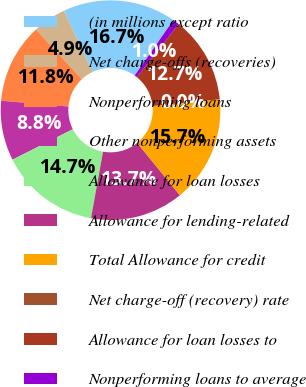Convert chart to OTSL. <chart><loc_0><loc_0><loc_500><loc_500><pie_chart><fcel>(in millions except ratio<fcel>Net charge-offs (recoveries)<fcel>Nonperforming loans<fcel>Other nonperforming assets<fcel>Allowance for loan losses<fcel>Allowance for lending-related<fcel>Total Allowance for credit<fcel>Net charge-off (recovery) rate<fcel>Allowance for loan losses to<fcel>Nonperforming loans to average<nl><fcel>16.67%<fcel>4.9%<fcel>11.76%<fcel>8.82%<fcel>14.71%<fcel>13.73%<fcel>15.69%<fcel>0.0%<fcel>12.75%<fcel>0.98%<nl></chart> 